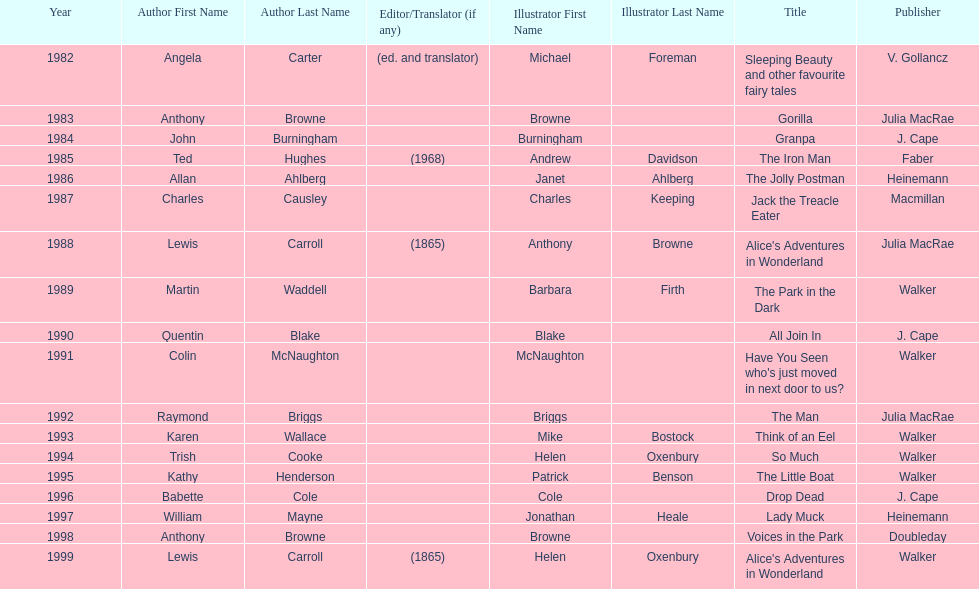What is the only title listed for 1999? Alice's Adventures in Wonderland. 